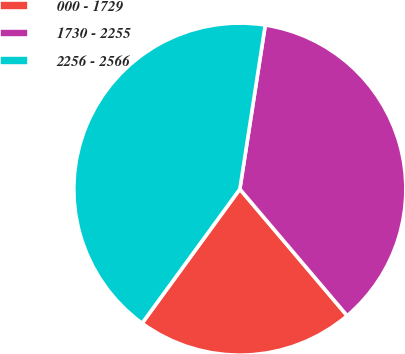Convert chart to OTSL. <chart><loc_0><loc_0><loc_500><loc_500><pie_chart><fcel>000 - 1729<fcel>1730 - 2255<fcel>2256 - 2566<nl><fcel>21.21%<fcel>36.36%<fcel>42.42%<nl></chart> 